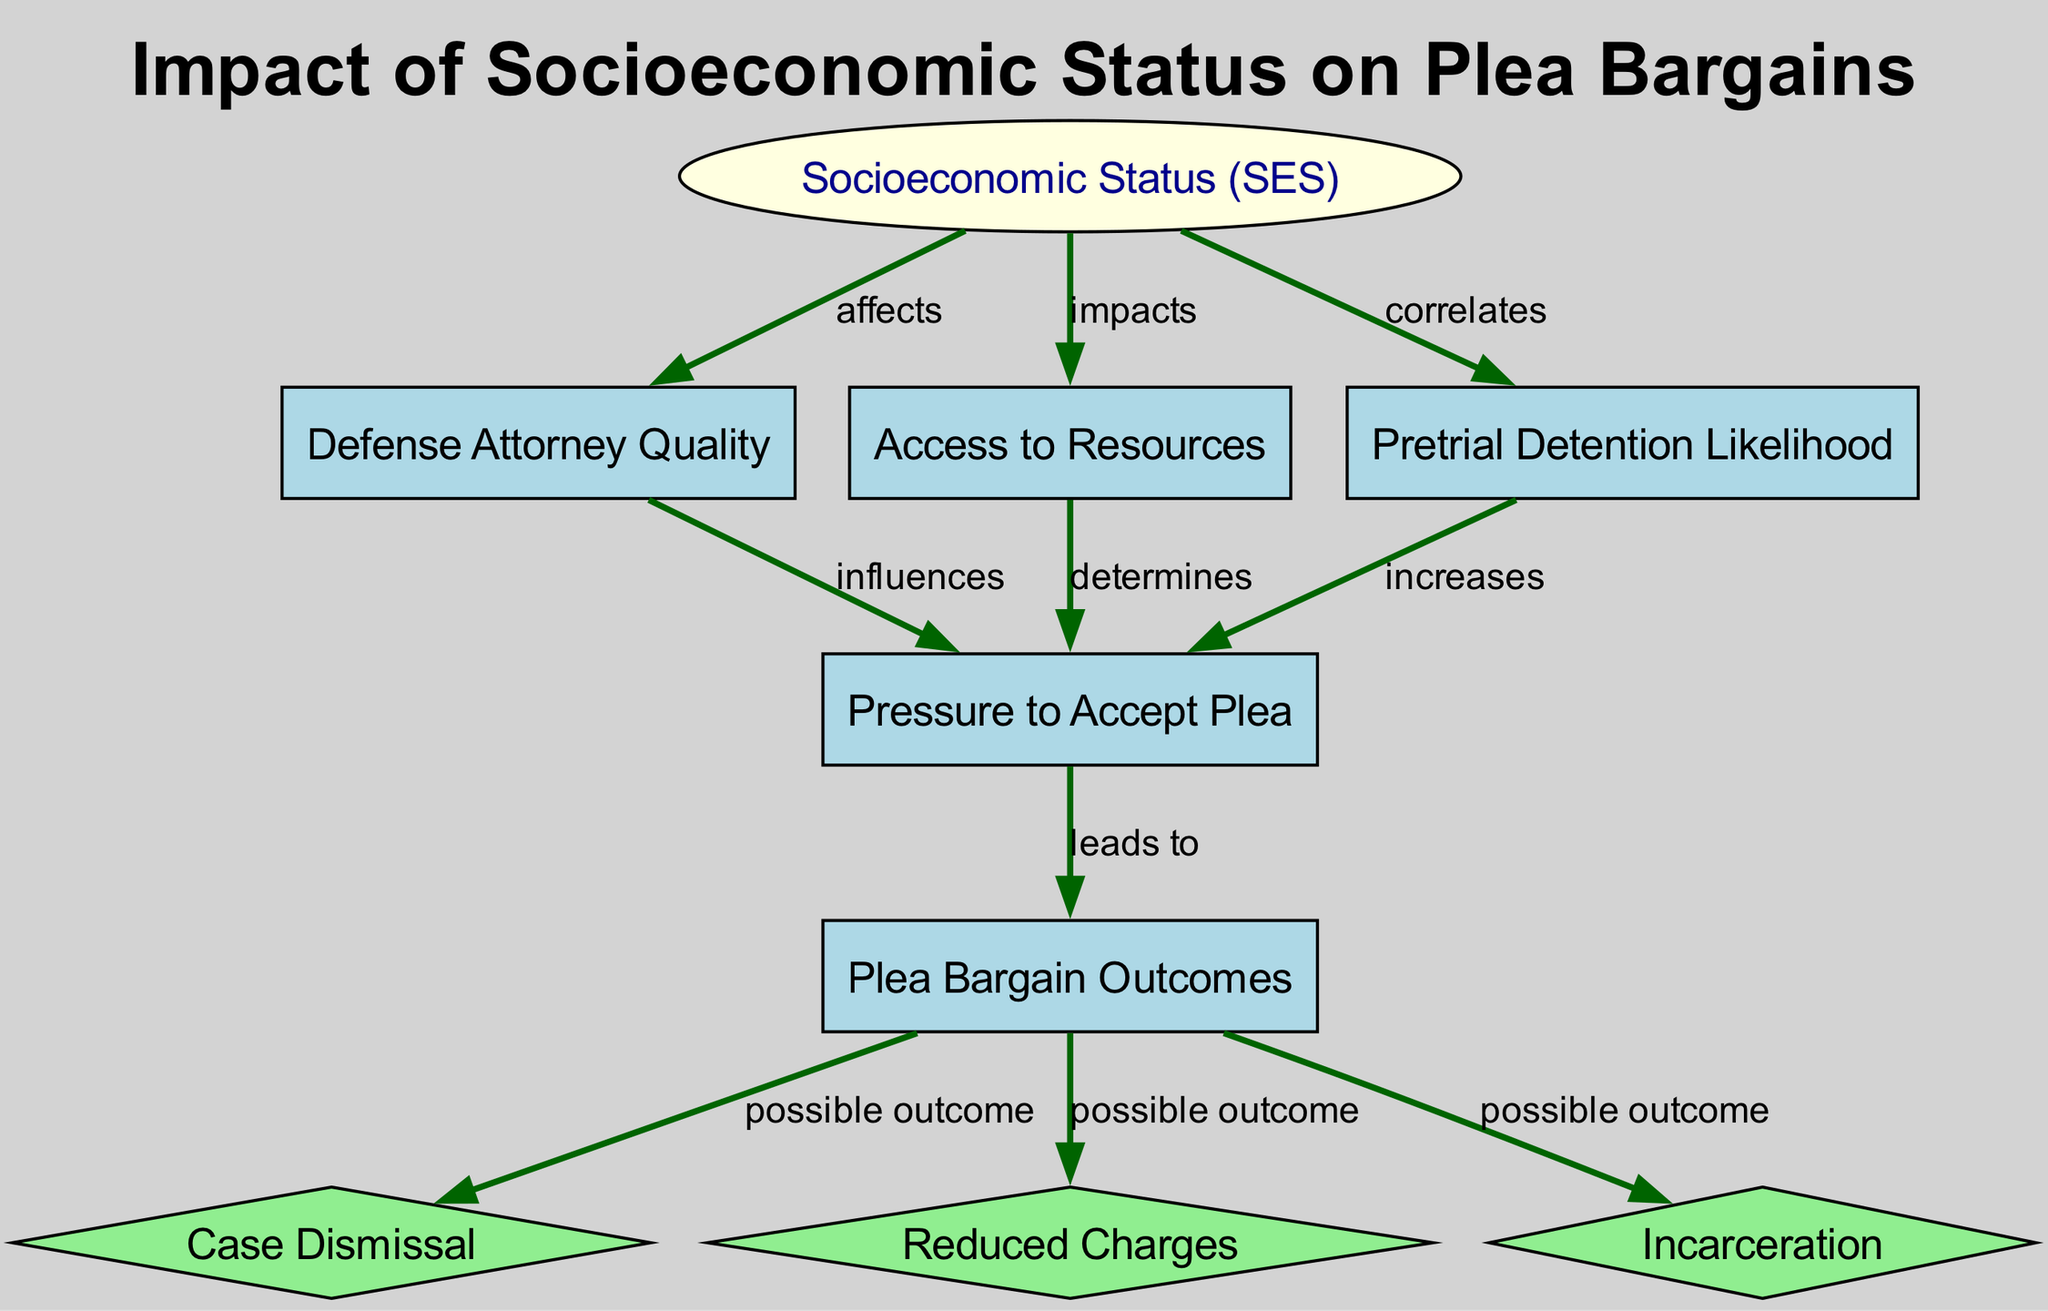What is the main factor influencing the quality of defense attorneys? According to the diagram, the quality of defense attorneys is affected by socioeconomic status, as indicated by the "affects" relationship between nodes 1 (Socioeconomic Status) and 2 (Defense Attorney Quality).
Answer: Socioeconomic Status How many possible outcomes are shown for plea bargain outcomes? The diagram outlines three possible outcomes for plea bargains: case dismissal, reduced charges, and incarceration, which are represented by nodes 7, 8, and 9 respectively. This can be confirmed by counting the edges leading from node 6 (Plea Bargain Outcomes).
Answer: 3 What plays a role in increasing the pressure to accept a plea? The diagram shows that the likelihood of pretrial detention correlates with an increase in the pressure to accept a plea, as indicated by the edge labeled "increases" from node 4 (Pretrial Detention Likelihood) to node 5 (Pressure to Accept Plea).
Answer: Pretrial Detention Likelihood Which factor determines the pressure to accept a plea? The access to resources determined the pressure to accept a plea, represented by the "determines" edge from node 3 (Access to Resources) to node 5 (Pressure to Accept Plea).
Answer: Access to Resources What type of node is “Plea Bargain Outcomes”? The node labeled "Plea Bargain Outcomes" (node 6) is categorized as a regular node, not an ellipse or a diamond, as its purpose is to represent the outcomes of the interplay of other factors in the diagram.
Answer: Regular node 